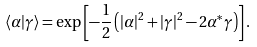<formula> <loc_0><loc_0><loc_500><loc_500>\langle \alpha | \gamma \rangle = \exp \left [ - \frac { 1 } { 2 } \left ( | \alpha | ^ { 2 } + | \gamma | ^ { 2 } - 2 \alpha ^ { * } \gamma \right ) \right ] .</formula> 